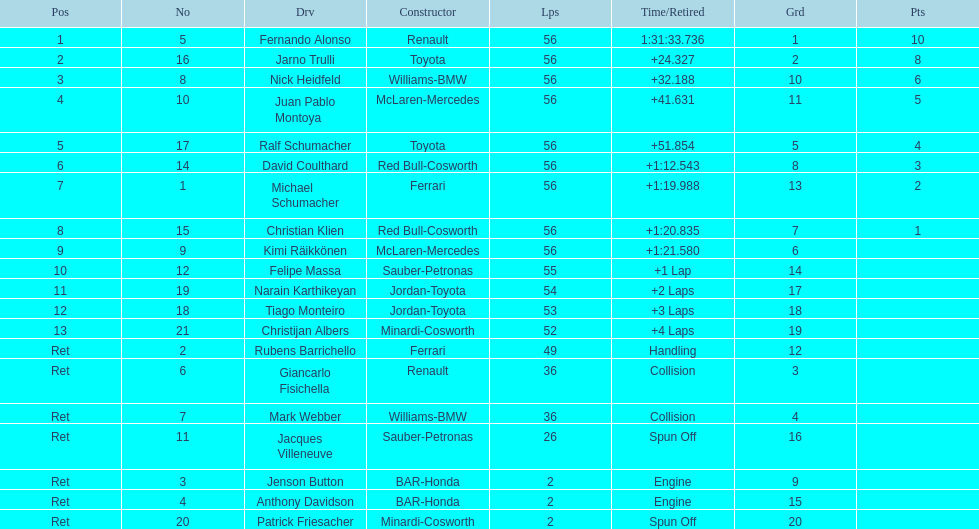Jarno trulli was not french but what nationality? Italian. 